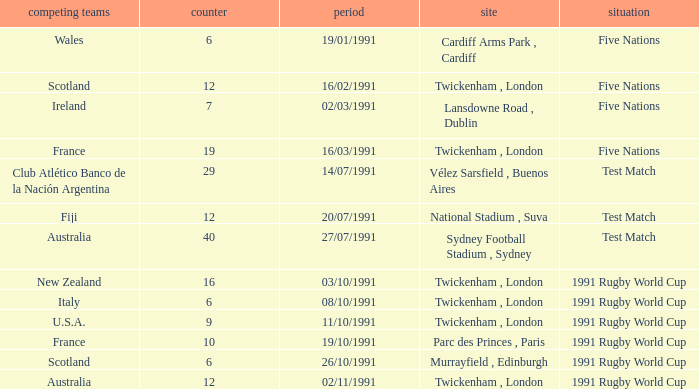What is Venue, when Status is "Test Match", and when Against is "12"? National Stadium , Suva. 